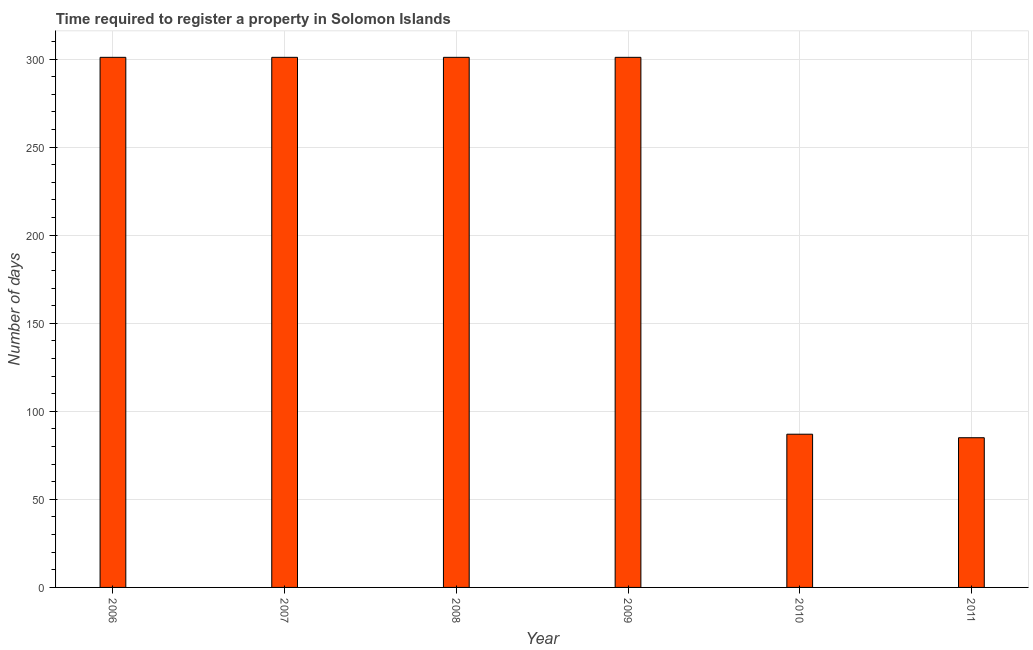What is the title of the graph?
Keep it short and to the point. Time required to register a property in Solomon Islands. What is the label or title of the X-axis?
Make the answer very short. Year. What is the label or title of the Y-axis?
Your answer should be compact. Number of days. What is the number of days required to register property in 2008?
Your response must be concise. 301. Across all years, what is the maximum number of days required to register property?
Your response must be concise. 301. In which year was the number of days required to register property maximum?
Keep it short and to the point. 2006. In which year was the number of days required to register property minimum?
Provide a short and direct response. 2011. What is the sum of the number of days required to register property?
Ensure brevity in your answer.  1376. What is the difference between the number of days required to register property in 2008 and 2010?
Provide a succinct answer. 214. What is the average number of days required to register property per year?
Provide a succinct answer. 229.33. What is the median number of days required to register property?
Offer a terse response. 301. Do a majority of the years between 2006 and 2007 (inclusive) have number of days required to register property greater than 170 days?
Provide a succinct answer. Yes. What is the ratio of the number of days required to register property in 2006 to that in 2008?
Ensure brevity in your answer.  1. What is the difference between the highest and the second highest number of days required to register property?
Keep it short and to the point. 0. What is the difference between the highest and the lowest number of days required to register property?
Provide a succinct answer. 216. Are all the bars in the graph horizontal?
Offer a very short reply. No. What is the difference between two consecutive major ticks on the Y-axis?
Offer a terse response. 50. Are the values on the major ticks of Y-axis written in scientific E-notation?
Keep it short and to the point. No. What is the Number of days of 2006?
Provide a short and direct response. 301. What is the Number of days of 2007?
Ensure brevity in your answer.  301. What is the Number of days in 2008?
Your answer should be compact. 301. What is the Number of days in 2009?
Your response must be concise. 301. What is the difference between the Number of days in 2006 and 2007?
Your response must be concise. 0. What is the difference between the Number of days in 2006 and 2008?
Provide a short and direct response. 0. What is the difference between the Number of days in 2006 and 2009?
Provide a short and direct response. 0. What is the difference between the Number of days in 2006 and 2010?
Offer a terse response. 214. What is the difference between the Number of days in 2006 and 2011?
Keep it short and to the point. 216. What is the difference between the Number of days in 2007 and 2008?
Your response must be concise. 0. What is the difference between the Number of days in 2007 and 2010?
Your answer should be very brief. 214. What is the difference between the Number of days in 2007 and 2011?
Your answer should be very brief. 216. What is the difference between the Number of days in 2008 and 2010?
Provide a succinct answer. 214. What is the difference between the Number of days in 2008 and 2011?
Provide a short and direct response. 216. What is the difference between the Number of days in 2009 and 2010?
Ensure brevity in your answer.  214. What is the difference between the Number of days in 2009 and 2011?
Give a very brief answer. 216. What is the difference between the Number of days in 2010 and 2011?
Provide a succinct answer. 2. What is the ratio of the Number of days in 2006 to that in 2010?
Offer a terse response. 3.46. What is the ratio of the Number of days in 2006 to that in 2011?
Your response must be concise. 3.54. What is the ratio of the Number of days in 2007 to that in 2010?
Offer a terse response. 3.46. What is the ratio of the Number of days in 2007 to that in 2011?
Offer a very short reply. 3.54. What is the ratio of the Number of days in 2008 to that in 2010?
Your response must be concise. 3.46. What is the ratio of the Number of days in 2008 to that in 2011?
Your answer should be very brief. 3.54. What is the ratio of the Number of days in 2009 to that in 2010?
Offer a very short reply. 3.46. What is the ratio of the Number of days in 2009 to that in 2011?
Your response must be concise. 3.54. 